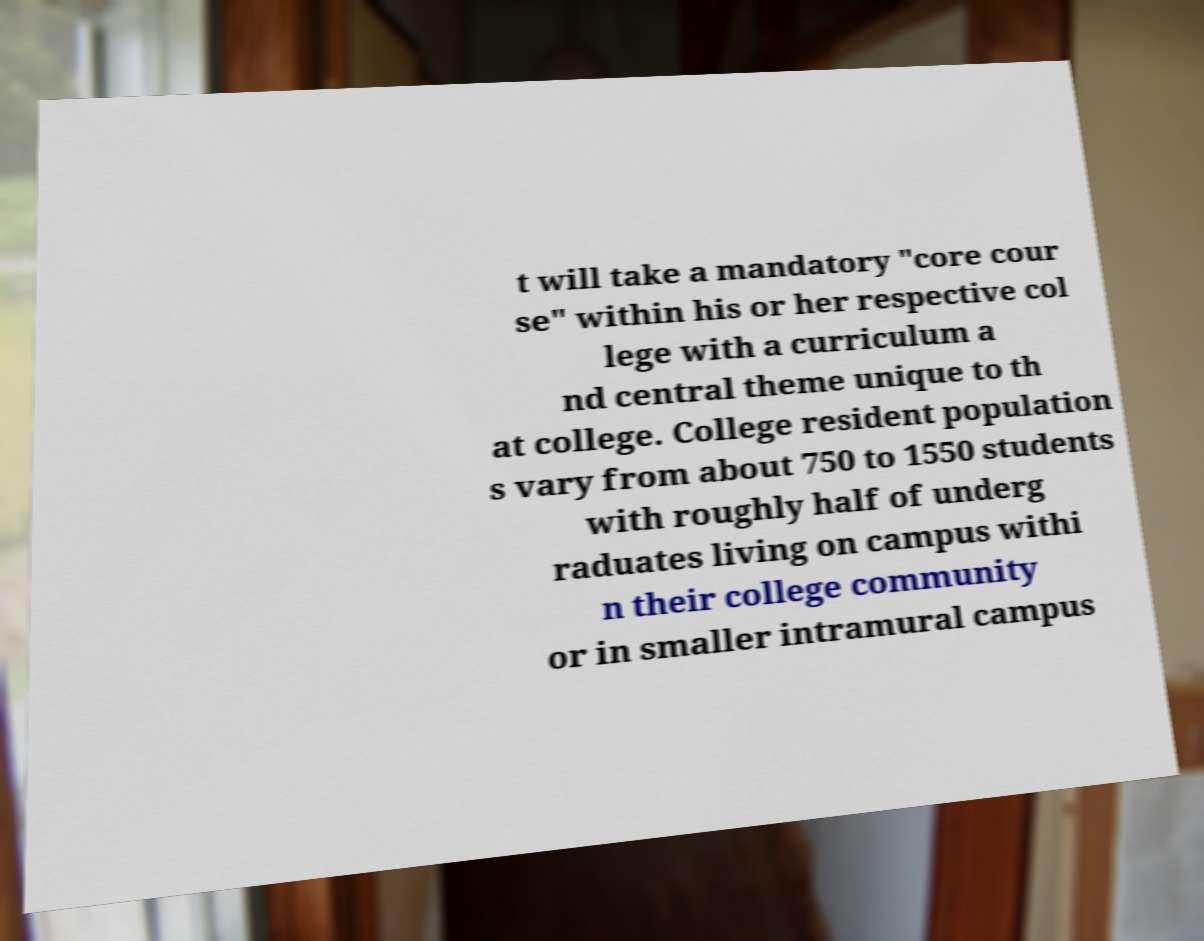Can you read and provide the text displayed in the image?This photo seems to have some interesting text. Can you extract and type it out for me? t will take a mandatory "core cour se" within his or her respective col lege with a curriculum a nd central theme unique to th at college. College resident population s vary from about 750 to 1550 students with roughly half of underg raduates living on campus withi n their college community or in smaller intramural campus 